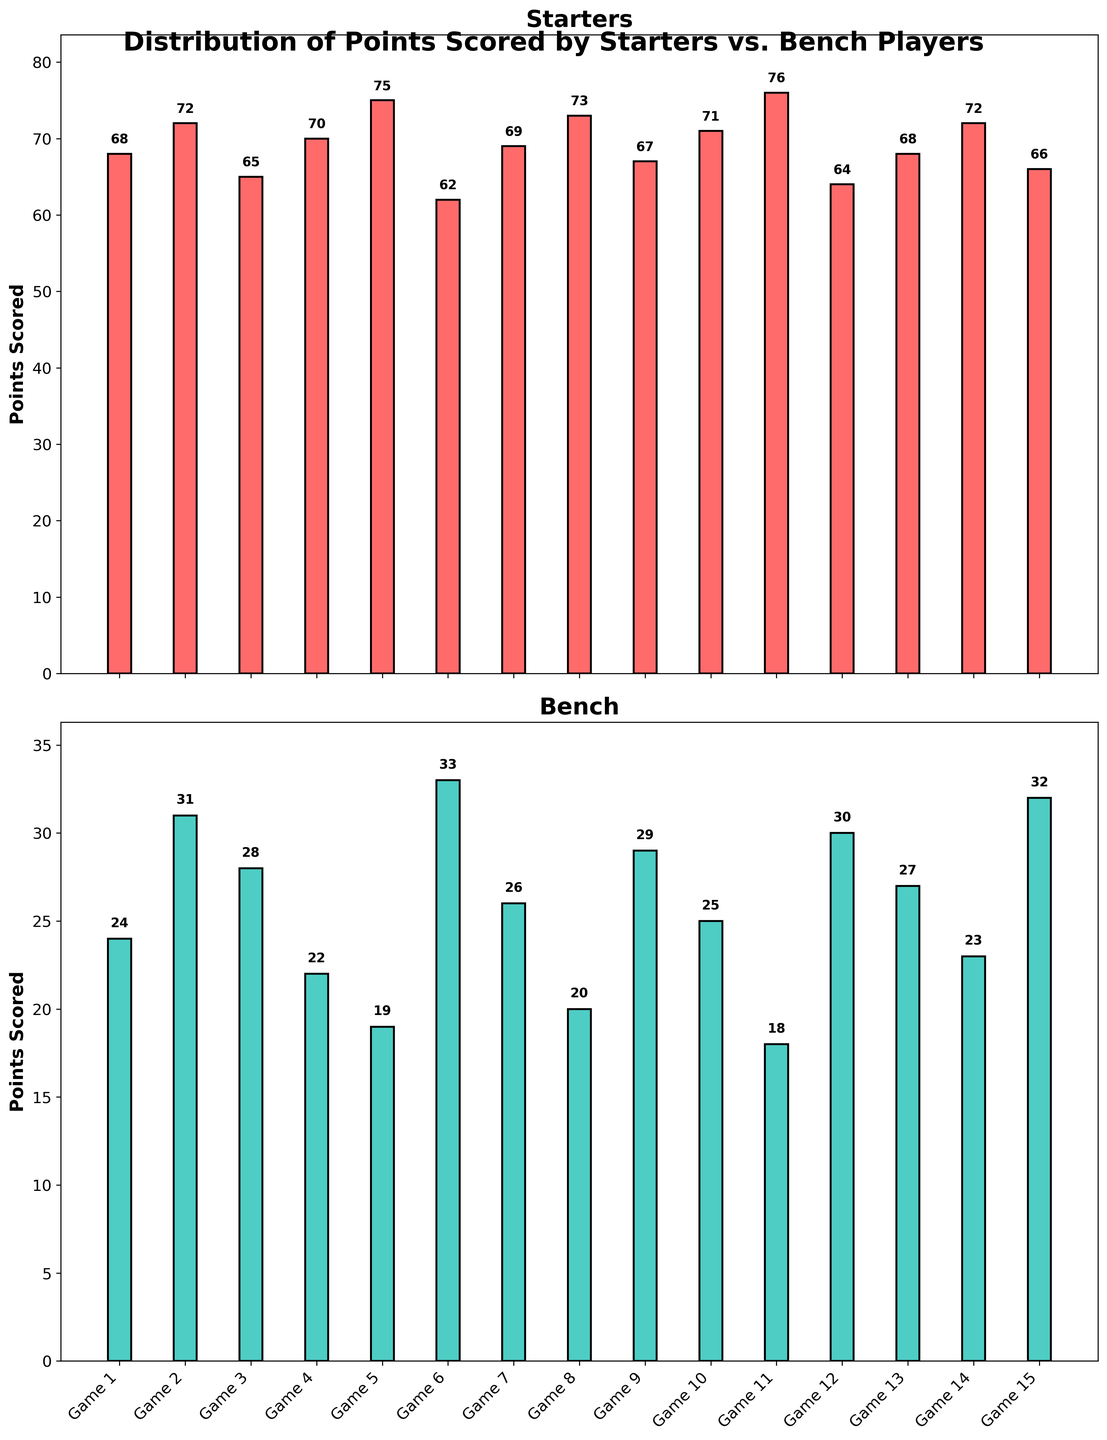Which game had the highest points scored by the starters? Identify the tallest red bar in the Starters subplot, which represents the highest points. The tallest bar is for Game 11 with 76 points.
Answer: Game 11 What is the total number of points scored by the bench across all games? Sum the points scored by the bench in all the games: 24 + 31 + 28 + 22 + 19 + 33 + 26 + 20 + 29 + 25 + 18 + 30 + 27 + 23 + 32 = 387.
Answer: 387 How many games did the bench score more than 30 points? Count the green bars in the Bench subplot where the height is more than 30 points. The bars corresponding to Game 6, Game 12, and Game 15 are above 30 points.
Answer: 3 What is the average number of points scored by the starters? Sum the points scored by the starters and divide by the number of games: (68 + 72 + 65 + 70 + 75 + 62 + 69 + 73 + 67 + 71 + 76 + 64 + 68 + 72 + 66) / 15 = 999 / 15 = 66.6.
Answer: 66.6 In which game did the bench score the least points? Identify the shortest green bar in the Bench subplot, which represents the least points. The shortest bar is for Game 11 with 18 points.
Answer: Game 11 Compare the points scored by the starters in Game 5 and Game 8. Which game had more points? Compare the heights of the red bars for Game 5 and Game 8. Game 5 scored 75 points, and Game 8 scored 73 points. Game 5 had more points.
Answer: Game 5 What is the difference between the highest and lowest points scored by the bench? Identify the highest and lowest points scored by the bench (33 in Game 6 and 18 in Game 11), then subtract the lowest from the highest: 33 - 18 = 15.
Answer: 15 In how many games did the starters score above 70 points? Count the red bars in the Starters subplot where the height is more than 70 points. The bars corresponding to Game 2, Game 5, Game 8, Game 11, and Game 14 are above 70 points.
Answer: 5 What is the combined total of points scored by both starters and bench in Game 7? Add the points scored by both starters and bench in Game 7: 69 (starters) + 26 (bench) = 95.
Answer: 95 